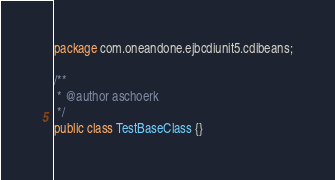Convert code to text. <code><loc_0><loc_0><loc_500><loc_500><_Java_>package com.oneandone.ejbcdiunit5.cdibeans;

/**
 * @author aschoerk
 */
public class TestBaseClass {}
</code> 